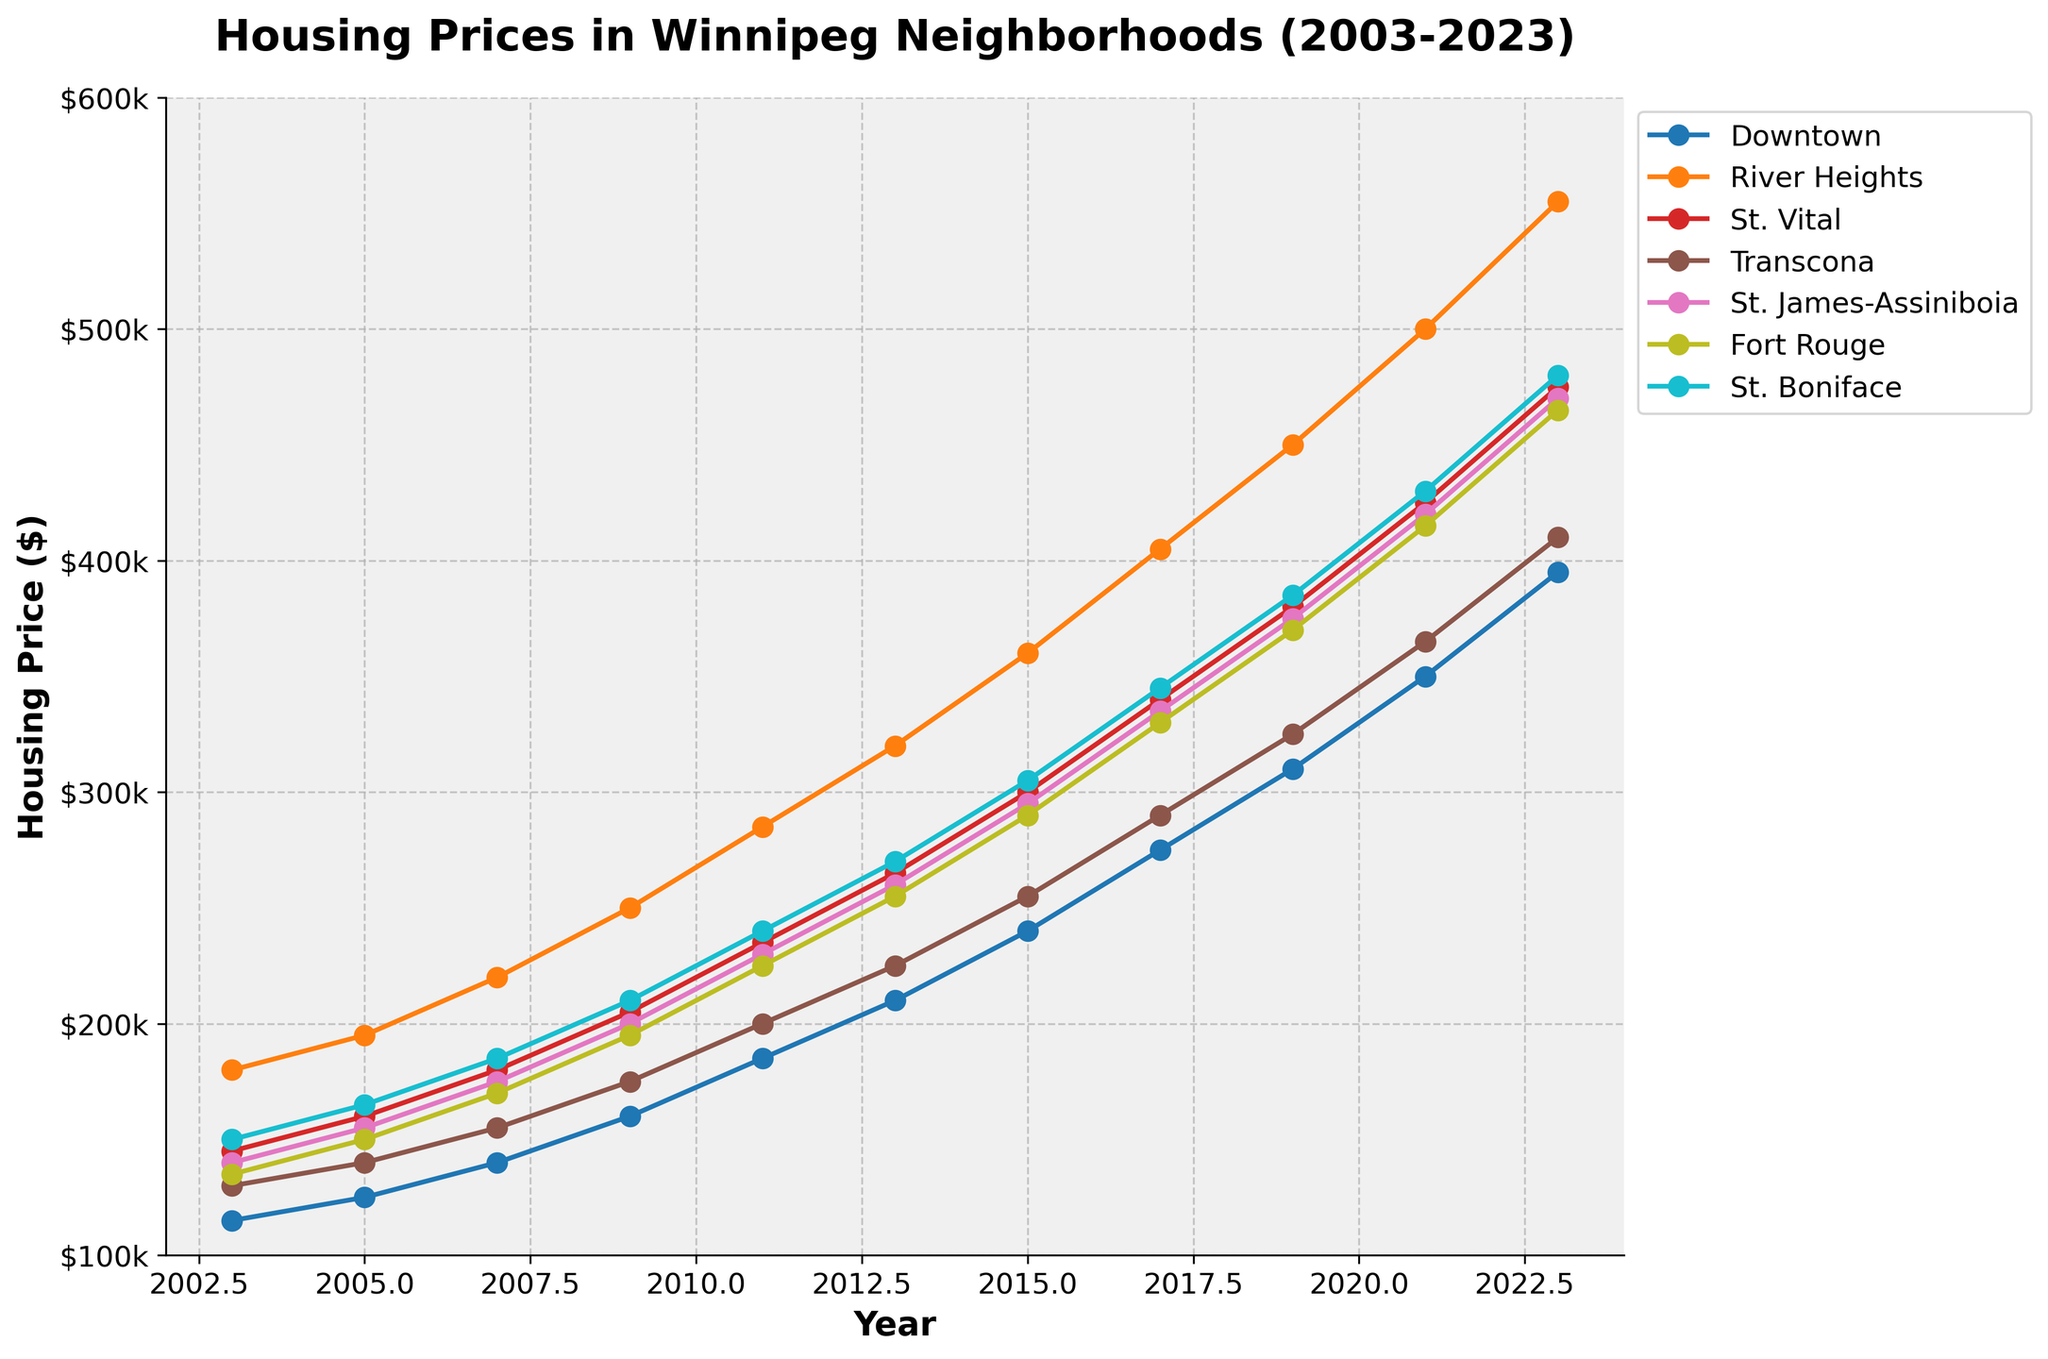Which neighborhood had the highest housing price in 2023? By visually comparing the end points of the lines for 2023, you can see that River Heights has the highest price.
Answer: River Heights Which neighborhood had the lowest housing price in 2003? By looking at the starting points of the lines for the year 2003, you can see that Downtown has the lowest price.
Answer: Downtown How much did the housing price in St. Vital increase from 2003 to 2023? Subtract the housing price in 2003 ($145,000) from the price in 2023 ($475,000): $475,000 - $145,000.
Answer: $330,000 Which neighborhood experienced the greatest increase in housing prices from 2003 to 2023? Compare the differences between the 2023 and 2003 prices for each neighborhood. River Heights had the largest increase, from $180,000 to $555,000.
Answer: River Heights Which two neighborhoods had the closest housing prices in 2023? Compare the 2023 values, River Heights ($555,000) and St. James-Assiniboia ($470,000) are the closest, with a $85,000 difference.
Answer: St. James-Assiniboia and River Heights In what year did Fort Rouge housing prices surpass $300,000? Follow the line representing Fort Rouge, it surpasses $300,000 around the year 2015.
Answer: 2015 How much did the housing prices in Downtown and St. Boniface differ in 2021? Subtract the Downtown price ($350,000) from the St. Boniface price ($430,000): $430,000 - $350,000.
Answer: $80,000 On average, how much did housing prices increase per year in Transcona from 2003 to 2023? (assume linear growth for simplicity) The total increase from 2003 ($130,000) to 2023 ($410,000) is $280,000 over 20 years. $280,000 / 20.
Answer: $14,000/year Which neighborhood showed the most consistent growth over the 20 years? By observing the smoothness and linearity of the lines, St. Boniface shows the most consistent growth without large fluctuations.
Answer: St. Boniface 